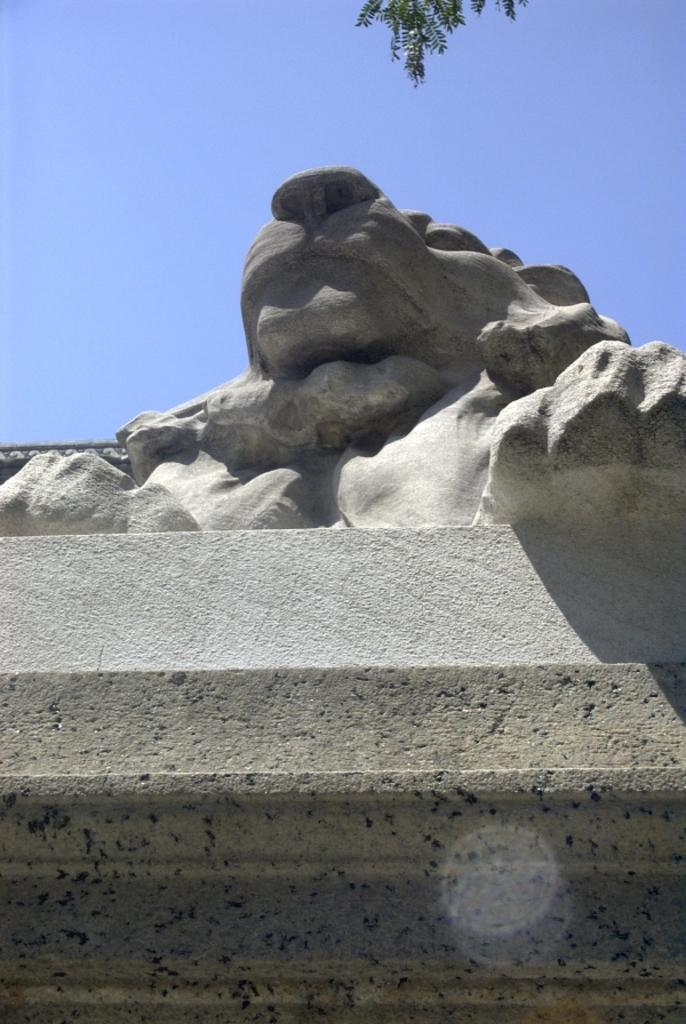What is the main subject of the image? There is a statue in the image. How is the statue positioned in the image? The statue is on a pedestal. What can be seen in the background of the image? There is sky visible in the background of the image. What type of vegetation is present at the top of the image? Leaves are present at the top of the image. What type of stocking is the statue wearing in the image? There is no stocking present on the statue in the image. What is the statue's desire in the image? The statue is an inanimate object and does not have desires. 